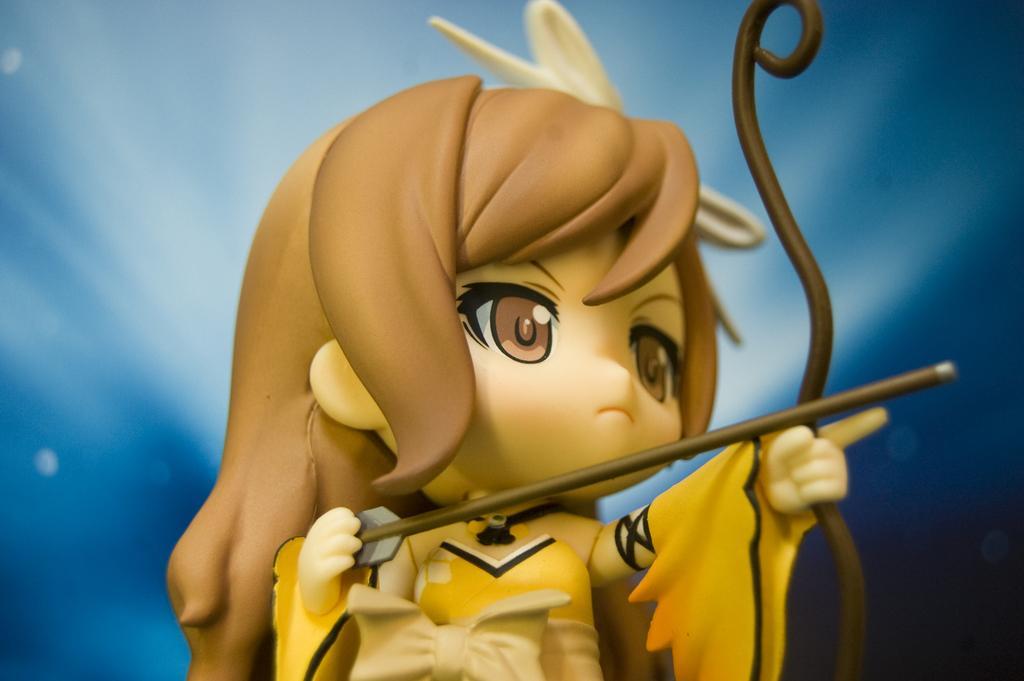Could you give a brief overview of what you see in this image? In this image I can see an animated toy and the toy is holding a bow and an arrow. The toy is wearing yellow and cream color dress and I can see blue color background. 